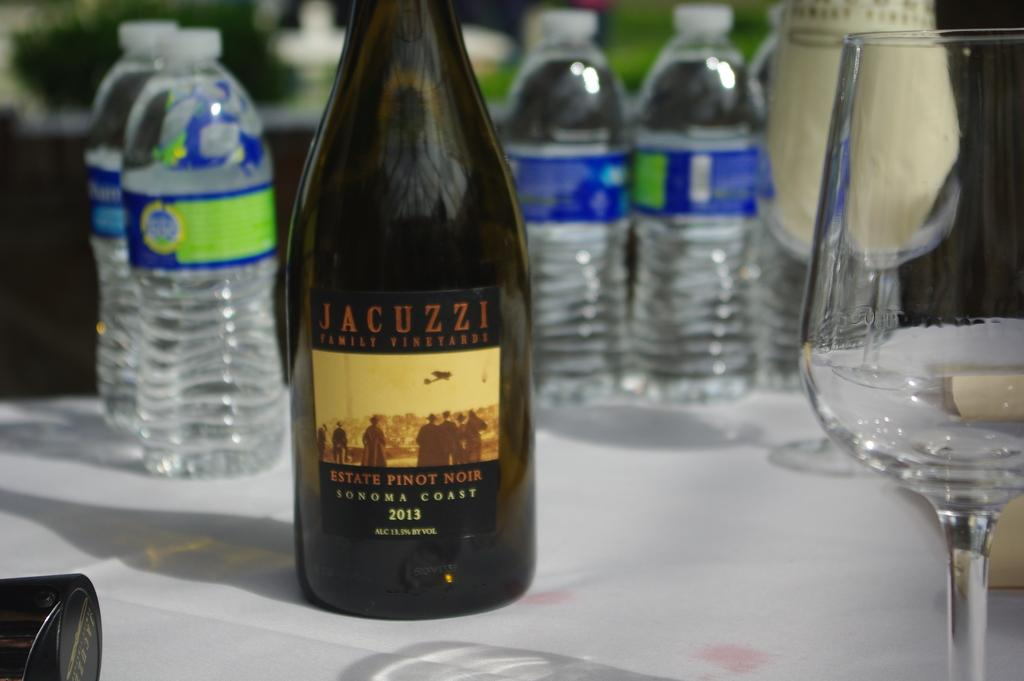<image>
Relay a brief, clear account of the picture shown. the word estate that is on a bottle 